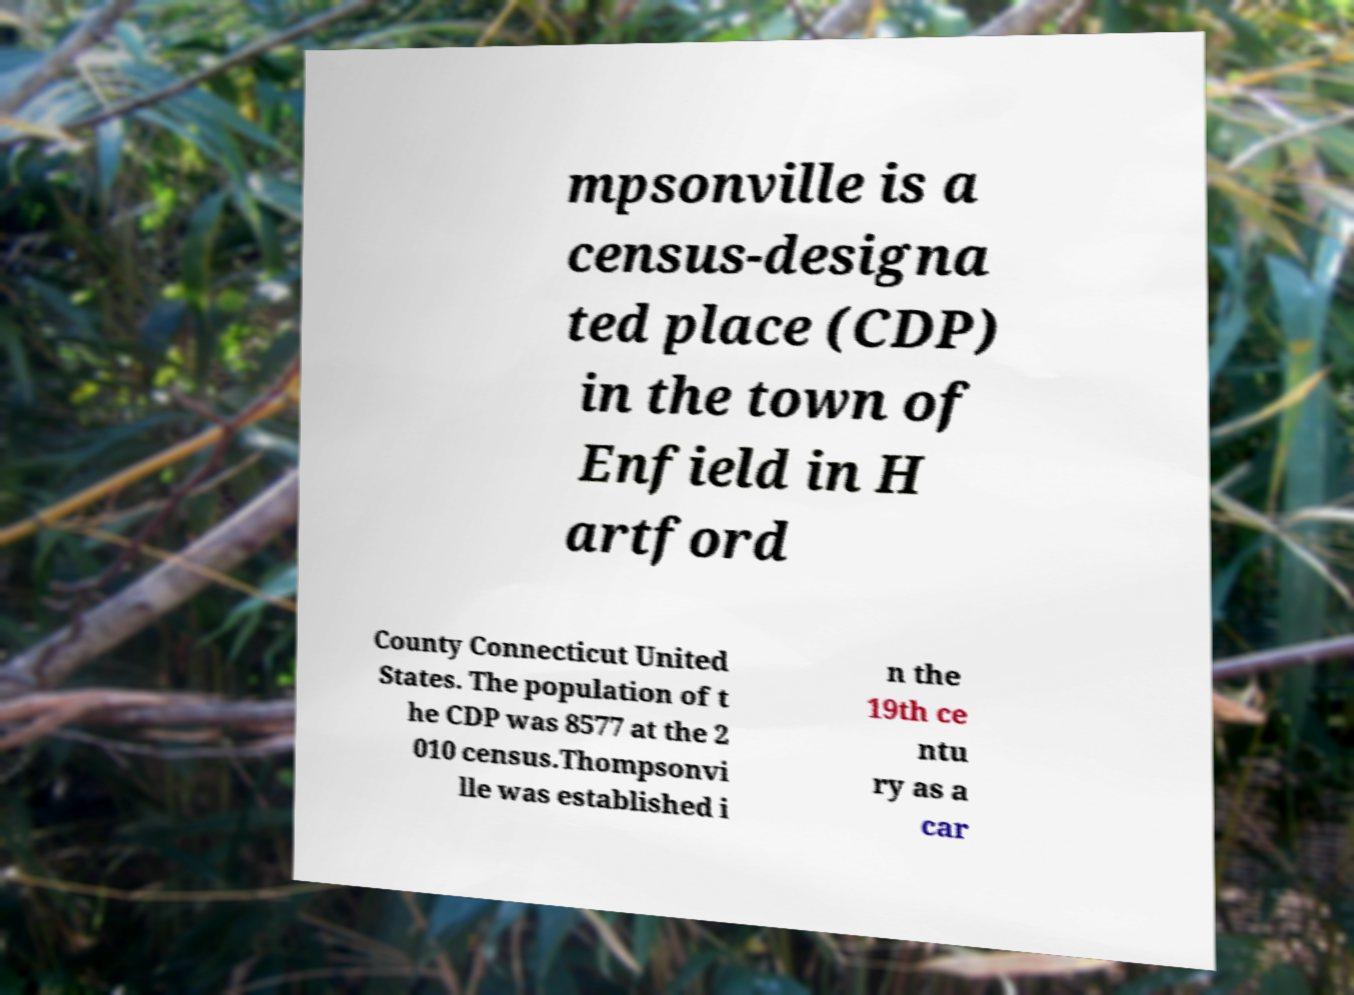Please read and relay the text visible in this image. What does it say? mpsonville is a census-designa ted place (CDP) in the town of Enfield in H artford County Connecticut United States. The population of t he CDP was 8577 at the 2 010 census.Thompsonvi lle was established i n the 19th ce ntu ry as a car 